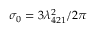Convert formula to latex. <formula><loc_0><loc_0><loc_500><loc_500>\sigma _ { 0 } = 3 \lambda _ { 4 2 1 } ^ { 2 } / 2 \pi</formula> 